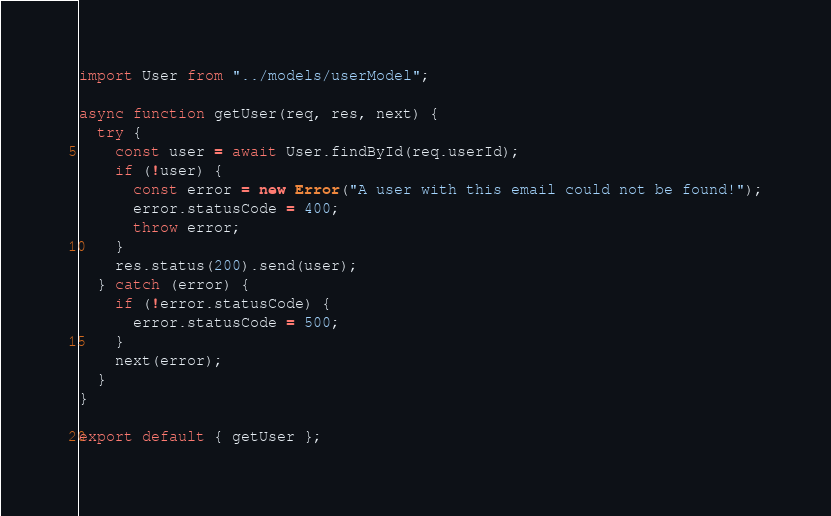<code> <loc_0><loc_0><loc_500><loc_500><_JavaScript_>import User from "../models/userModel";

async function getUser(req, res, next) {
  try {
    const user = await User.findById(req.userId);
    if (!user) {
      const error = new Error("A user with this email could not be found!");
      error.statusCode = 400;
      throw error;
    }
    res.status(200).send(user);
  } catch (error) {
    if (!error.statusCode) {
      error.statusCode = 500;
    }
    next(error);
  }
}

export default { getUser };
</code> 